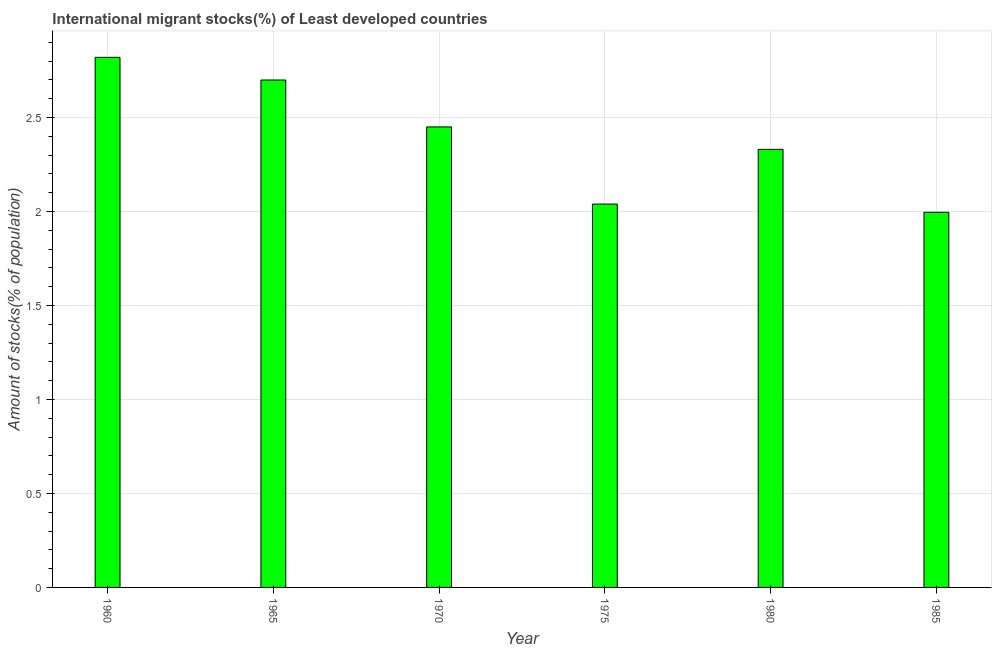Does the graph contain any zero values?
Your answer should be very brief. No. Does the graph contain grids?
Give a very brief answer. Yes. What is the title of the graph?
Provide a short and direct response. International migrant stocks(%) of Least developed countries. What is the label or title of the Y-axis?
Ensure brevity in your answer.  Amount of stocks(% of population). What is the number of international migrant stocks in 1960?
Offer a terse response. 2.82. Across all years, what is the maximum number of international migrant stocks?
Offer a very short reply. 2.82. Across all years, what is the minimum number of international migrant stocks?
Offer a very short reply. 2. What is the sum of the number of international migrant stocks?
Ensure brevity in your answer.  14.34. What is the difference between the number of international migrant stocks in 1960 and 1985?
Provide a short and direct response. 0.82. What is the average number of international migrant stocks per year?
Offer a very short reply. 2.39. What is the median number of international migrant stocks?
Offer a terse response. 2.39. What is the ratio of the number of international migrant stocks in 1970 to that in 1975?
Offer a very short reply. 1.2. Is the number of international migrant stocks in 1960 less than that in 1965?
Make the answer very short. No. What is the difference between the highest and the second highest number of international migrant stocks?
Keep it short and to the point. 0.12. What is the difference between the highest and the lowest number of international migrant stocks?
Provide a short and direct response. 0.82. Are all the bars in the graph horizontal?
Your answer should be very brief. No. How many years are there in the graph?
Keep it short and to the point. 6. Are the values on the major ticks of Y-axis written in scientific E-notation?
Offer a terse response. No. What is the Amount of stocks(% of population) in 1960?
Provide a short and direct response. 2.82. What is the Amount of stocks(% of population) of 1965?
Keep it short and to the point. 2.7. What is the Amount of stocks(% of population) of 1970?
Keep it short and to the point. 2.45. What is the Amount of stocks(% of population) of 1975?
Make the answer very short. 2.04. What is the Amount of stocks(% of population) of 1980?
Make the answer very short. 2.33. What is the Amount of stocks(% of population) in 1985?
Provide a short and direct response. 2. What is the difference between the Amount of stocks(% of population) in 1960 and 1965?
Your answer should be compact. 0.12. What is the difference between the Amount of stocks(% of population) in 1960 and 1970?
Provide a succinct answer. 0.37. What is the difference between the Amount of stocks(% of population) in 1960 and 1975?
Provide a short and direct response. 0.78. What is the difference between the Amount of stocks(% of population) in 1960 and 1980?
Your answer should be compact. 0.49. What is the difference between the Amount of stocks(% of population) in 1960 and 1985?
Ensure brevity in your answer.  0.82. What is the difference between the Amount of stocks(% of population) in 1965 and 1970?
Give a very brief answer. 0.25. What is the difference between the Amount of stocks(% of population) in 1965 and 1975?
Offer a terse response. 0.66. What is the difference between the Amount of stocks(% of population) in 1965 and 1980?
Provide a short and direct response. 0.37. What is the difference between the Amount of stocks(% of population) in 1965 and 1985?
Your answer should be very brief. 0.7. What is the difference between the Amount of stocks(% of population) in 1970 and 1975?
Your answer should be compact. 0.41. What is the difference between the Amount of stocks(% of population) in 1970 and 1980?
Your answer should be compact. 0.12. What is the difference between the Amount of stocks(% of population) in 1970 and 1985?
Your response must be concise. 0.45. What is the difference between the Amount of stocks(% of population) in 1975 and 1980?
Ensure brevity in your answer.  -0.29. What is the difference between the Amount of stocks(% of population) in 1975 and 1985?
Your response must be concise. 0.04. What is the difference between the Amount of stocks(% of population) in 1980 and 1985?
Your answer should be compact. 0.33. What is the ratio of the Amount of stocks(% of population) in 1960 to that in 1965?
Ensure brevity in your answer.  1.04. What is the ratio of the Amount of stocks(% of population) in 1960 to that in 1970?
Your answer should be very brief. 1.15. What is the ratio of the Amount of stocks(% of population) in 1960 to that in 1975?
Keep it short and to the point. 1.38. What is the ratio of the Amount of stocks(% of population) in 1960 to that in 1980?
Your answer should be compact. 1.21. What is the ratio of the Amount of stocks(% of population) in 1960 to that in 1985?
Your answer should be very brief. 1.41. What is the ratio of the Amount of stocks(% of population) in 1965 to that in 1970?
Offer a very short reply. 1.1. What is the ratio of the Amount of stocks(% of population) in 1965 to that in 1975?
Offer a very short reply. 1.32. What is the ratio of the Amount of stocks(% of population) in 1965 to that in 1980?
Provide a short and direct response. 1.16. What is the ratio of the Amount of stocks(% of population) in 1965 to that in 1985?
Keep it short and to the point. 1.35. What is the ratio of the Amount of stocks(% of population) in 1970 to that in 1975?
Your answer should be very brief. 1.2. What is the ratio of the Amount of stocks(% of population) in 1970 to that in 1980?
Offer a very short reply. 1.05. What is the ratio of the Amount of stocks(% of population) in 1970 to that in 1985?
Your answer should be compact. 1.23. What is the ratio of the Amount of stocks(% of population) in 1975 to that in 1980?
Offer a terse response. 0.88. What is the ratio of the Amount of stocks(% of population) in 1975 to that in 1985?
Your response must be concise. 1.02. What is the ratio of the Amount of stocks(% of population) in 1980 to that in 1985?
Provide a succinct answer. 1.17. 